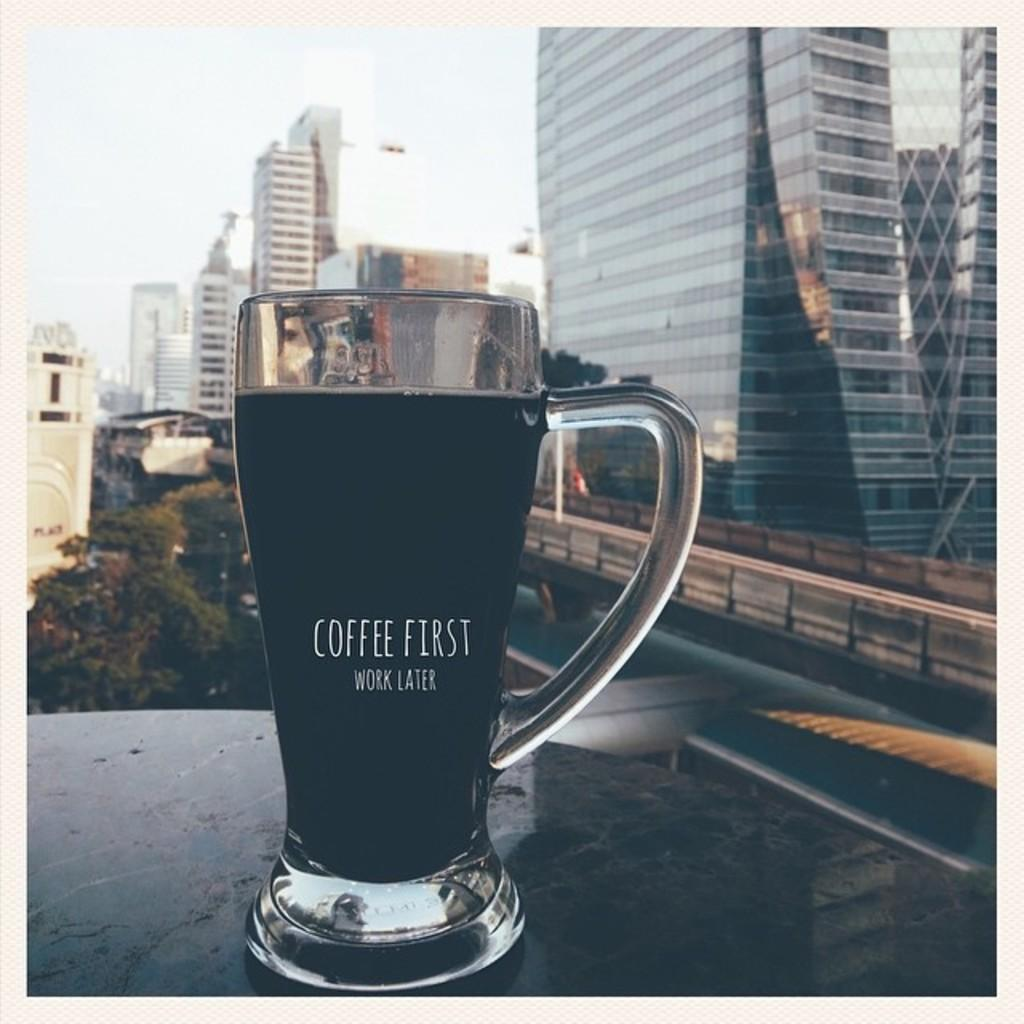<image>
Create a compact narrative representing the image presented. a glass that says coffee first on it 